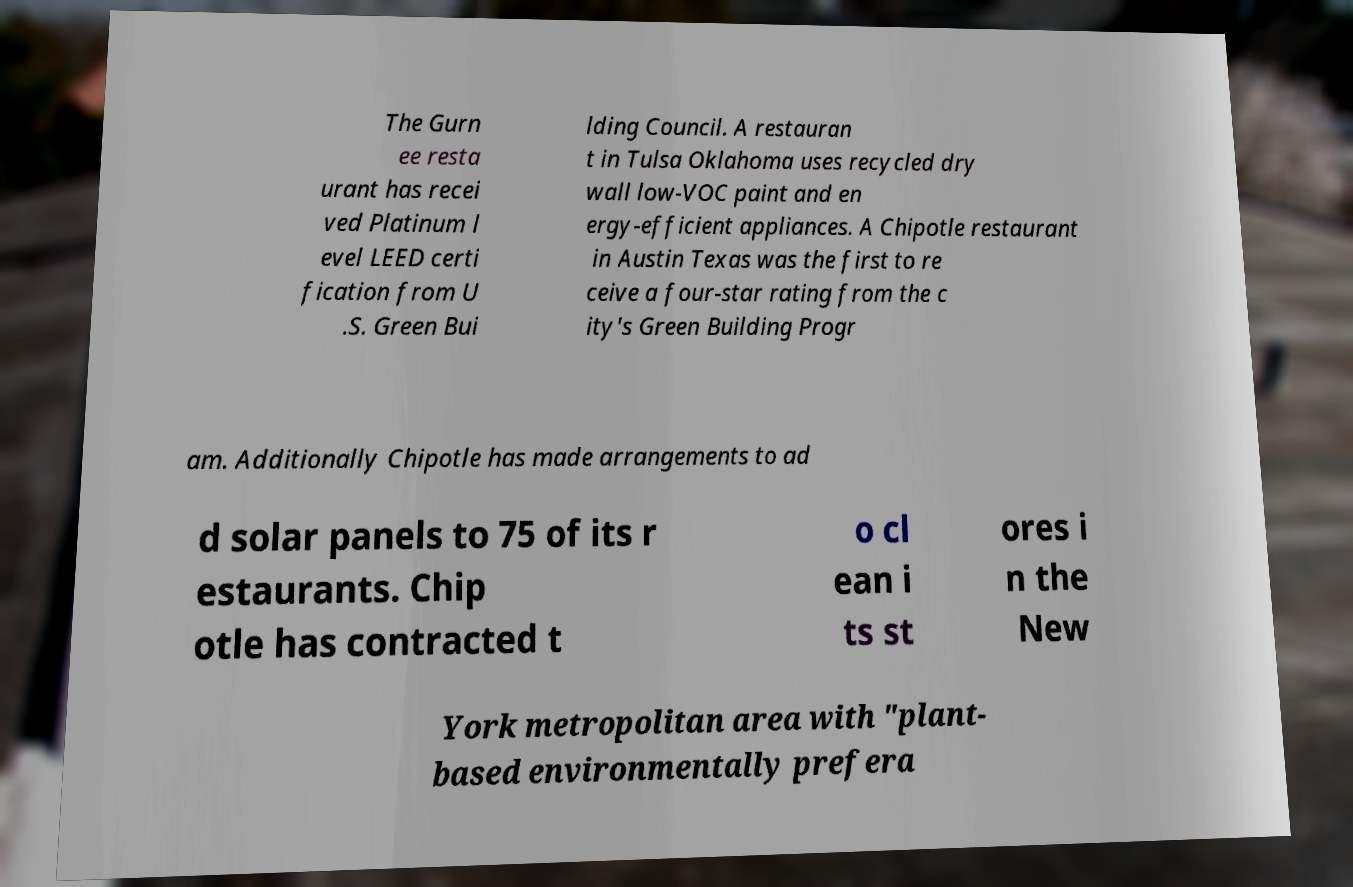Can you accurately transcribe the text from the provided image for me? The Gurn ee resta urant has recei ved Platinum l evel LEED certi fication from U .S. Green Bui lding Council. A restauran t in Tulsa Oklahoma uses recycled dry wall low-VOC paint and en ergy-efficient appliances. A Chipotle restaurant in Austin Texas was the first to re ceive a four-star rating from the c ity's Green Building Progr am. Additionally Chipotle has made arrangements to ad d solar panels to 75 of its r estaurants. Chip otle has contracted t o cl ean i ts st ores i n the New York metropolitan area with "plant- based environmentally prefera 